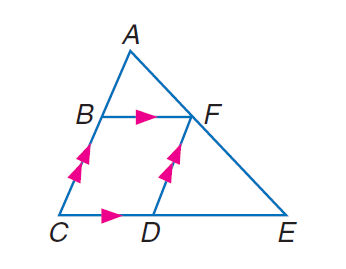Answer the mathemtical geometry problem and directly provide the correct option letter.
Question: Find C D if A B = 6, A F = 8, B C = x, C D = y, D E = 2 y - 3, and F E = x + \frac { 10 } { 3 }.
Choices: A: 9 B: 10 C: 12 D: 15 A 